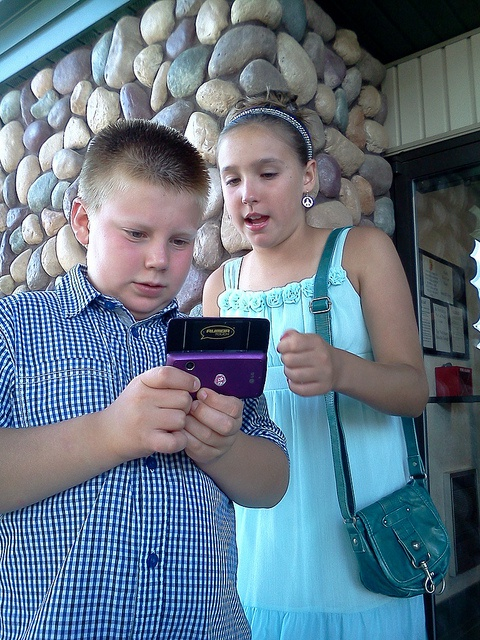Describe the objects in this image and their specific colors. I can see people in lightblue, navy, gray, darkgray, and white tones, people in lightblue, gray, and teal tones, handbag in lightblue, teal, darkblue, and black tones, and cell phone in lightblue, black, navy, gray, and purple tones in this image. 